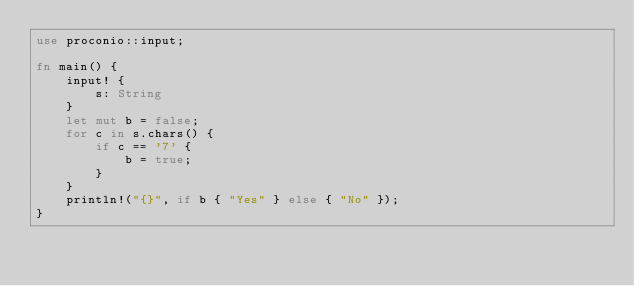<code> <loc_0><loc_0><loc_500><loc_500><_Rust_>use proconio::input;

fn main() {
    input! {
        s: String
    }
    let mut b = false;
    for c in s.chars() {
        if c == '7' {
            b = true;
        }
    }
    println!("{}", if b { "Yes" } else { "No" });
}
</code> 